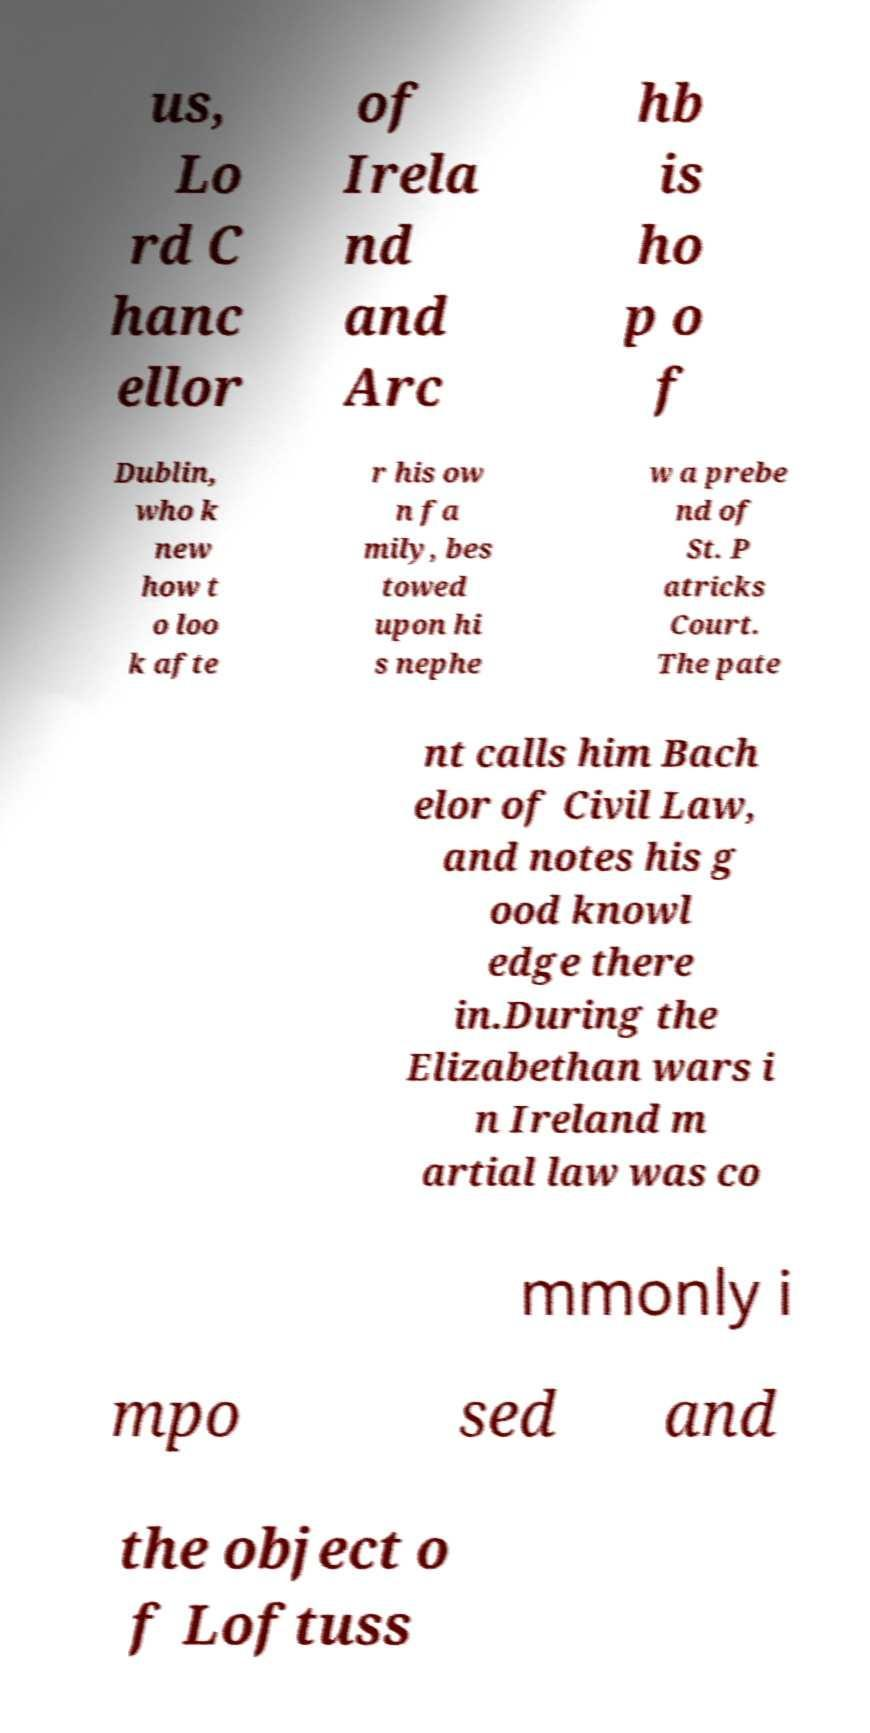Can you accurately transcribe the text from the provided image for me? us, Lo rd C hanc ellor of Irela nd and Arc hb is ho p o f Dublin, who k new how t o loo k afte r his ow n fa mily, bes towed upon hi s nephe w a prebe nd of St. P atricks Court. The pate nt calls him Bach elor of Civil Law, and notes his g ood knowl edge there in.During the Elizabethan wars i n Ireland m artial law was co mmonly i mpo sed and the object o f Loftuss 